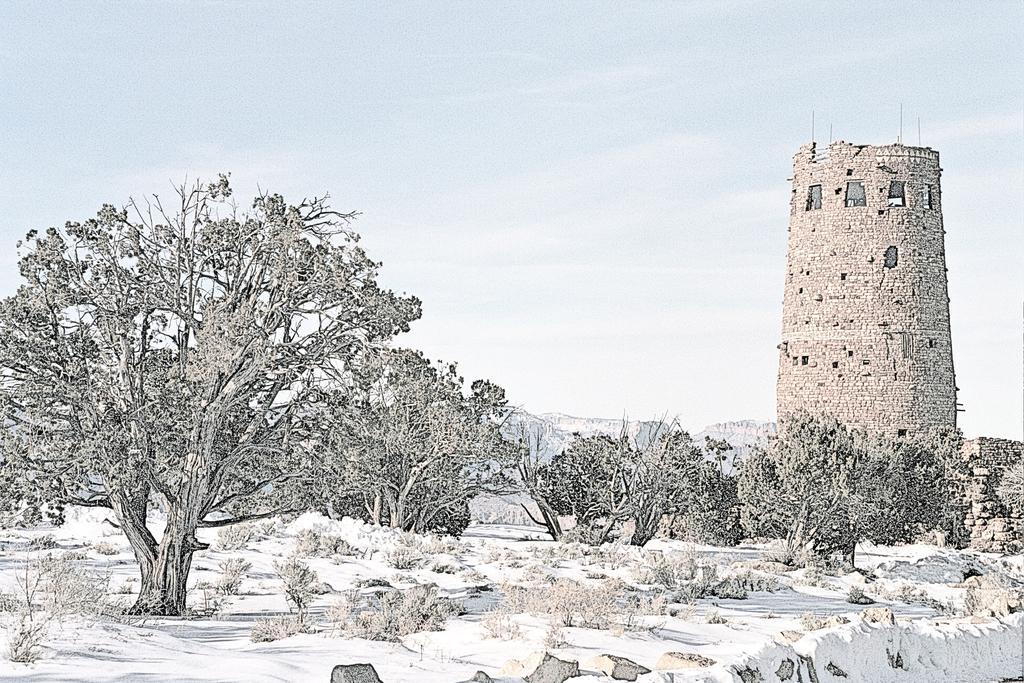Could you give a brief overview of what you see in this image? In this image there is a tower, trees, plants, the ground covered with snow and the sky. 